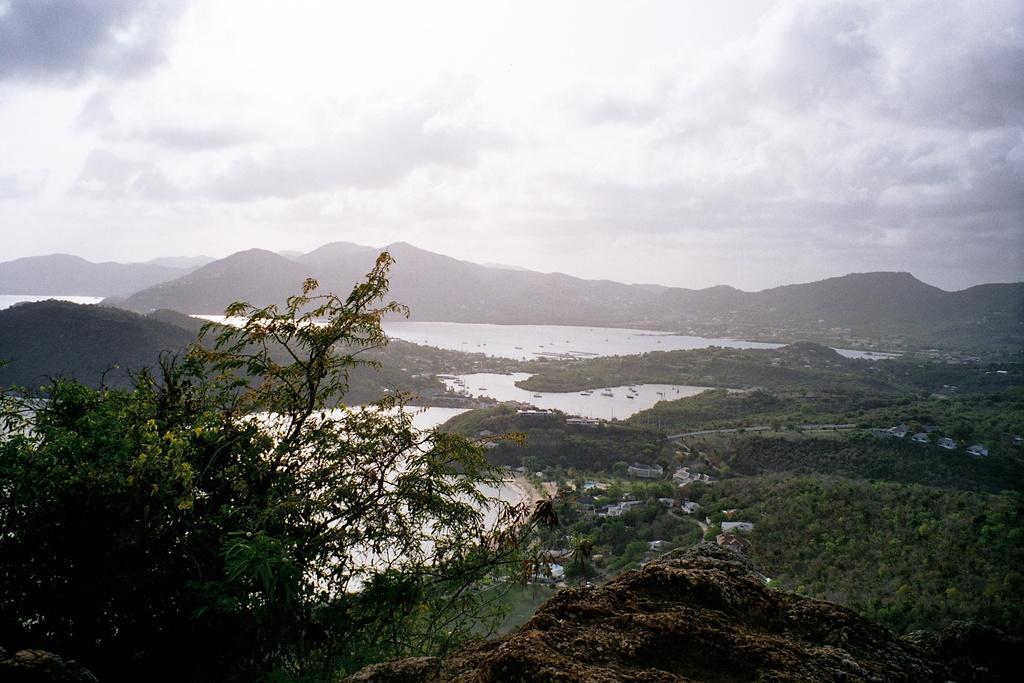In one or two sentences, can you explain what this image depicts? In the picture we can see some plant on the rock surface and in the background, we can see water and surface with plants in it and far from it we can see hills and sky with clouds. 